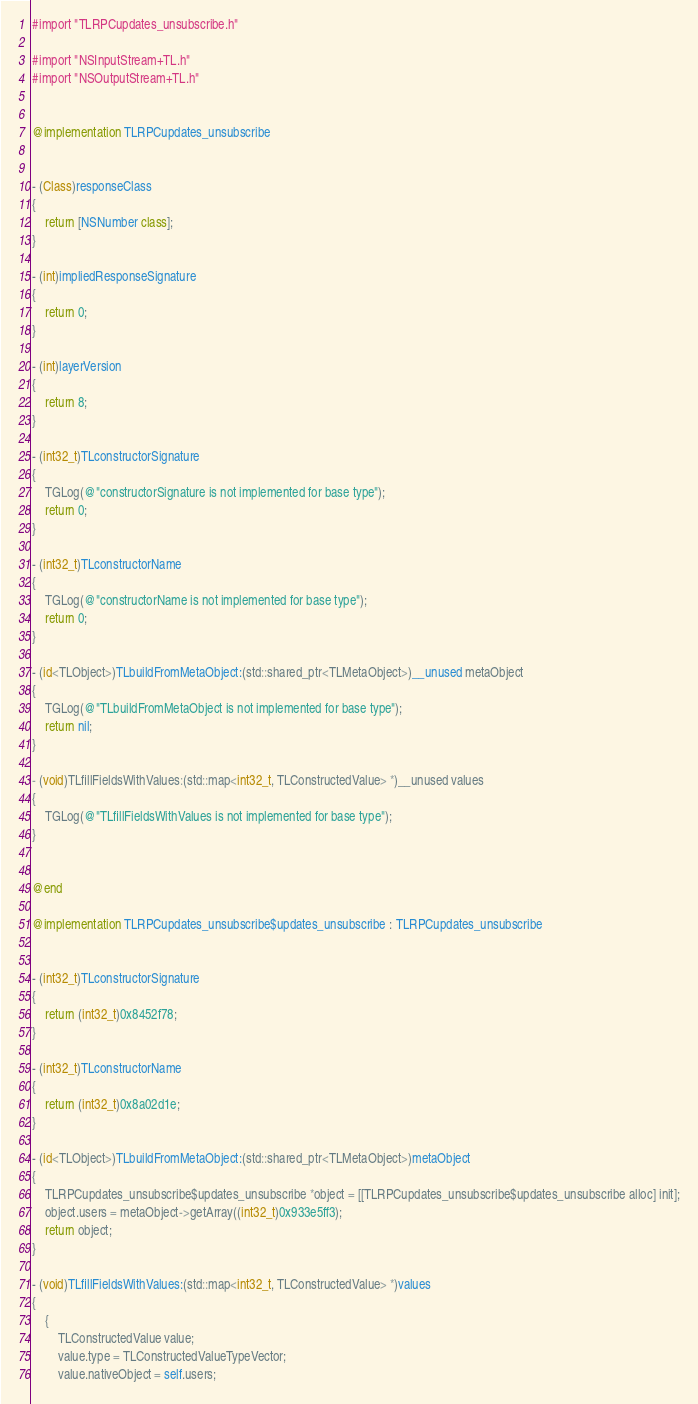Convert code to text. <code><loc_0><loc_0><loc_500><loc_500><_ObjectiveC_>#import "TLRPCupdates_unsubscribe.h"

#import "NSInputStream+TL.h"
#import "NSOutputStream+TL.h"


@implementation TLRPCupdates_unsubscribe


- (Class)responseClass
{
    return [NSNumber class];
}

- (int)impliedResponseSignature
{
    return 0;
}

- (int)layerVersion
{
    return 8;
}

- (int32_t)TLconstructorSignature
{
    TGLog(@"constructorSignature is not implemented for base type");
    return 0;
}

- (int32_t)TLconstructorName
{
    TGLog(@"constructorName is not implemented for base type");
    return 0;
}

- (id<TLObject>)TLbuildFromMetaObject:(std::shared_ptr<TLMetaObject>)__unused metaObject
{
    TGLog(@"TLbuildFromMetaObject is not implemented for base type");
    return nil;
}

- (void)TLfillFieldsWithValues:(std::map<int32_t, TLConstructedValue> *)__unused values
{
    TGLog(@"TLfillFieldsWithValues is not implemented for base type");
}


@end

@implementation TLRPCupdates_unsubscribe$updates_unsubscribe : TLRPCupdates_unsubscribe


- (int32_t)TLconstructorSignature
{
    return (int32_t)0x8452f78;
}

- (int32_t)TLconstructorName
{
    return (int32_t)0x8a02d1e;
}

- (id<TLObject>)TLbuildFromMetaObject:(std::shared_ptr<TLMetaObject>)metaObject
{
    TLRPCupdates_unsubscribe$updates_unsubscribe *object = [[TLRPCupdates_unsubscribe$updates_unsubscribe alloc] init];
    object.users = metaObject->getArray((int32_t)0x933e5ff3);
    return object;
}

- (void)TLfillFieldsWithValues:(std::map<int32_t, TLConstructedValue> *)values
{
    {
        TLConstructedValue value;
        value.type = TLConstructedValueTypeVector;
        value.nativeObject = self.users;</code> 